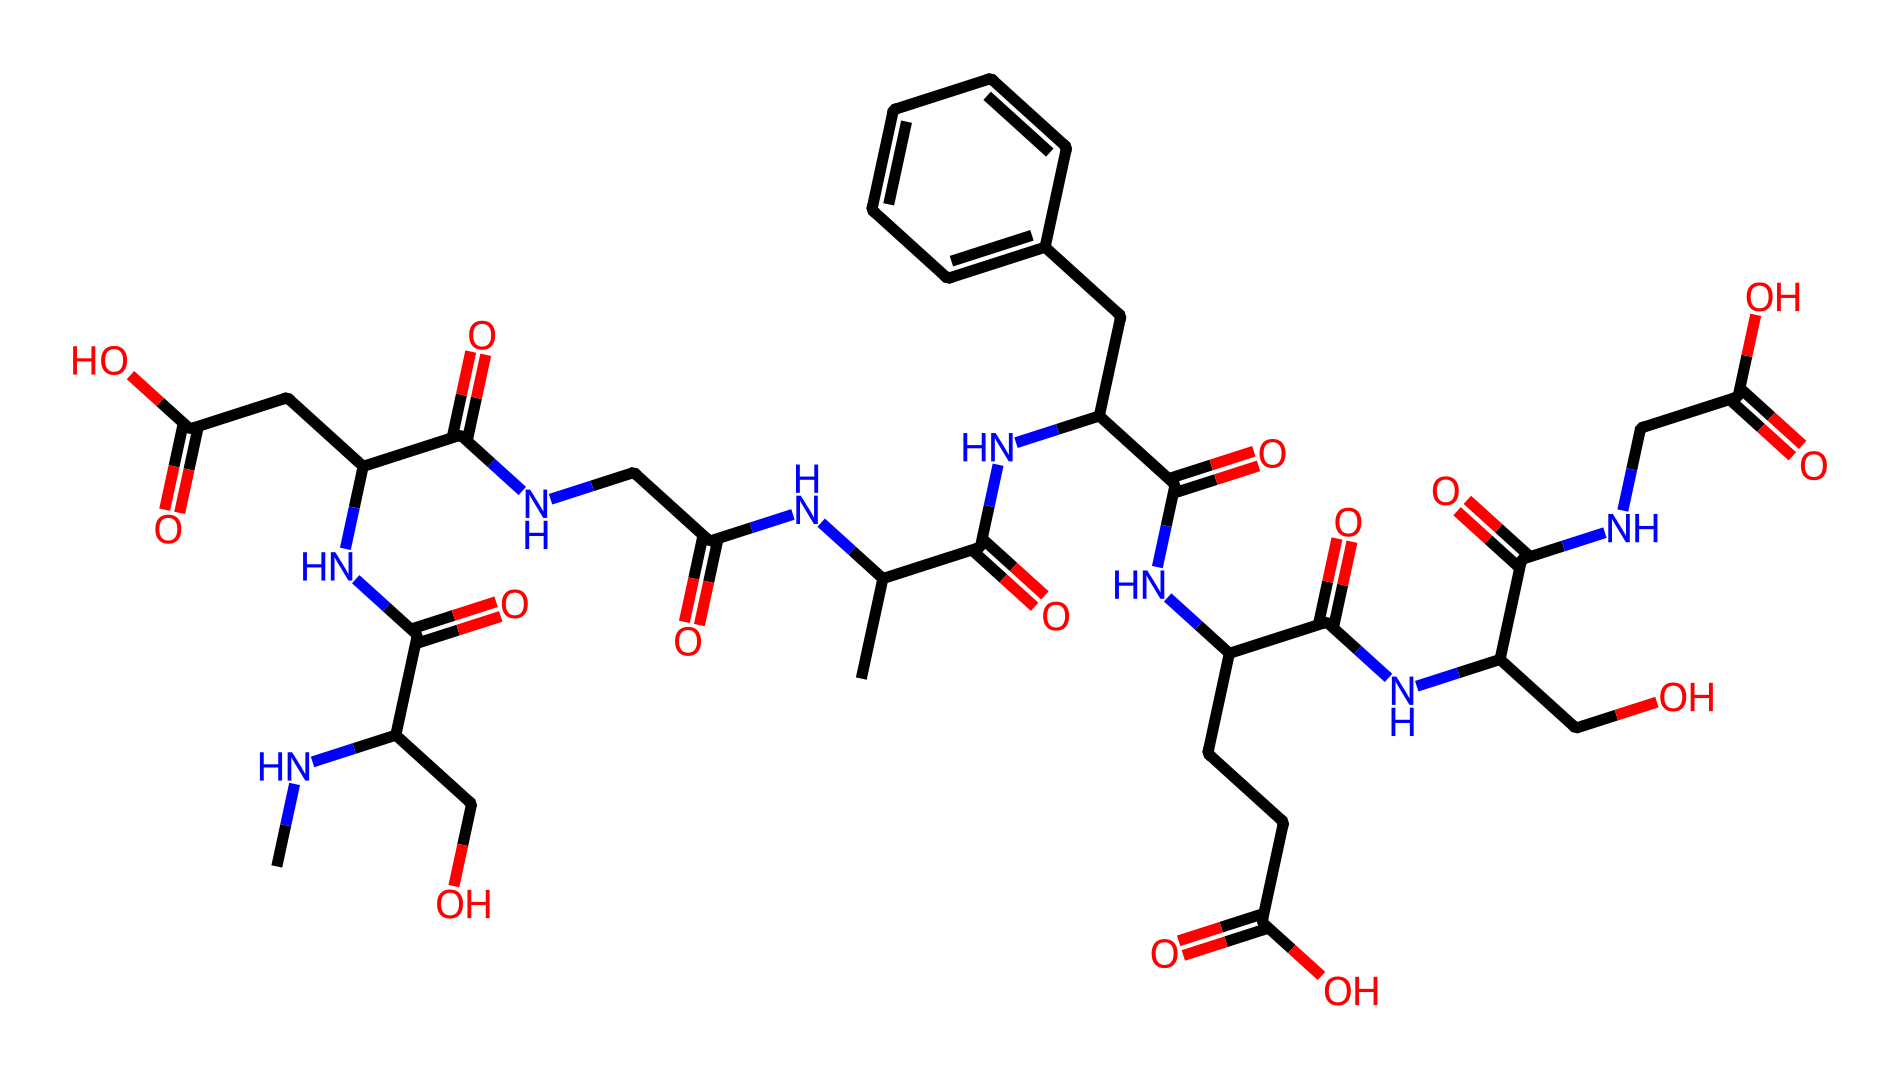How many carbon atoms are present in this chemical? By examining the entire SMILES representation, we can identify each carbon atom indicated by 'C'. Count all instances of 'C', considering any that are part of groups (like '-O' for esters) and those within rings. The total adds up to 24 carbon atoms.
Answer: 24 What functional groups are present in this chemical? The SMILES indicates the presence of amino (–NH), carboxylic acid (–COOH), and ester (–COOR) functional groups. Identifying the parts of the structure that show these characteristics allows for their classification.
Answer: amino, carboxylic acid, ester How many ester linkages are found in the chemical? Within the SMILES structure, we can identify ester linkages by looking for ‘-C(=O)O-’ sequences. Counting these provides insight into how many ester linkages are present. In this case, there are three ester linkages.
Answer: 3 What is the role of the nitrogen atoms in this chemical? The nitrogen atoms in the structure suggest the presence of amides or amino groups, which are integral in stabilizing the structure and maintaining adhesive properties through hydrogen bonding in adhesive applications.
Answer: stabilizing structure Which part of the chemical structure contributes to its adhesive properties? The presence of polar functional groups, such as amides and esters, contributes to good adhesive qualities by enhancing intermolecular interactions. Analyzing these specific groups closely shows their contribution to adhesion.
Answer: polar functional groups 